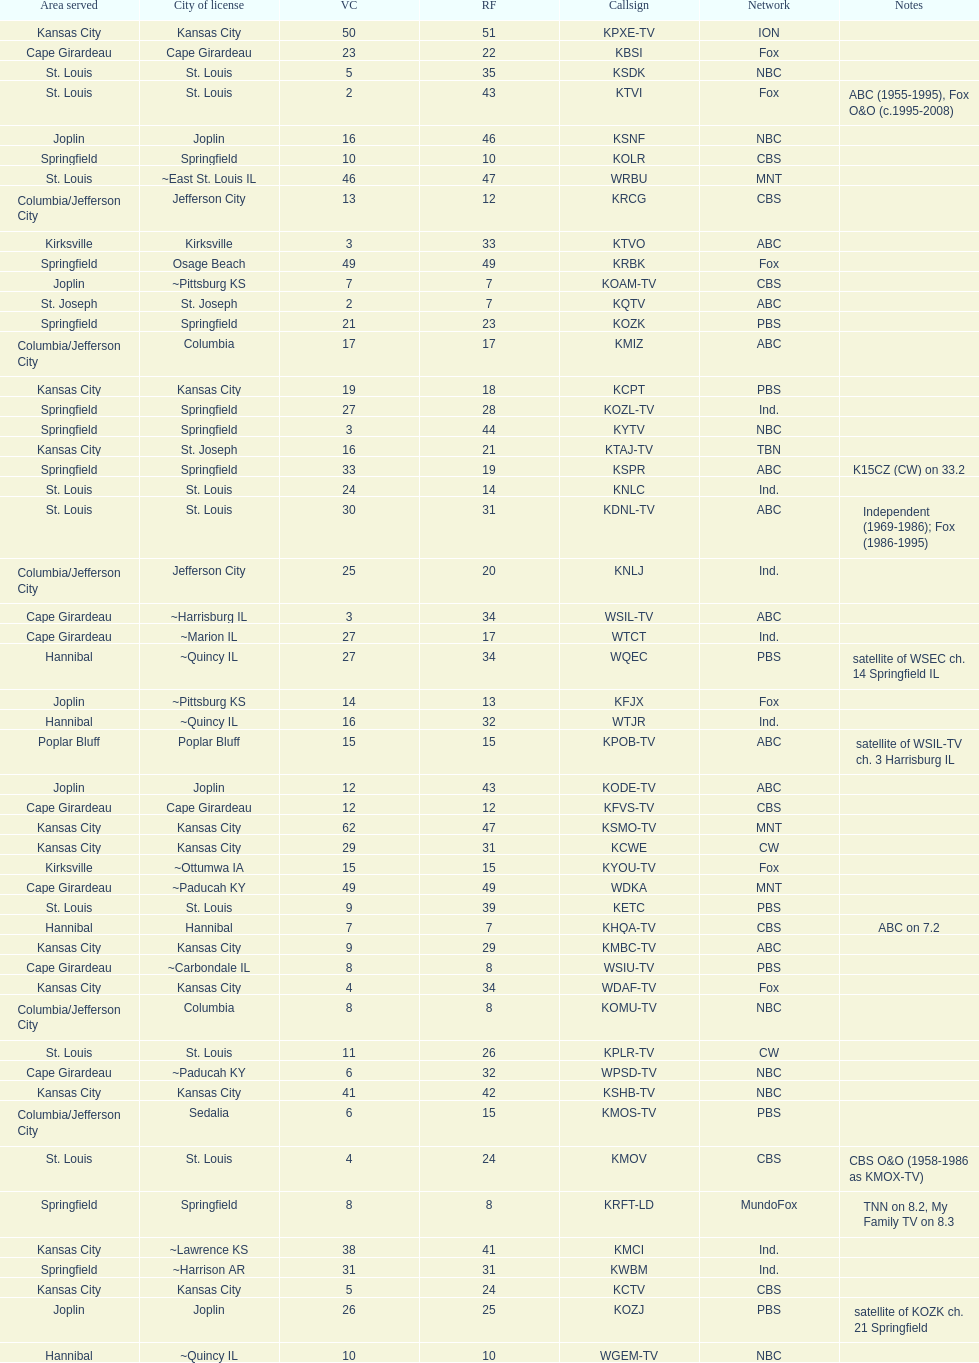How many are on the cbs network? 7. 